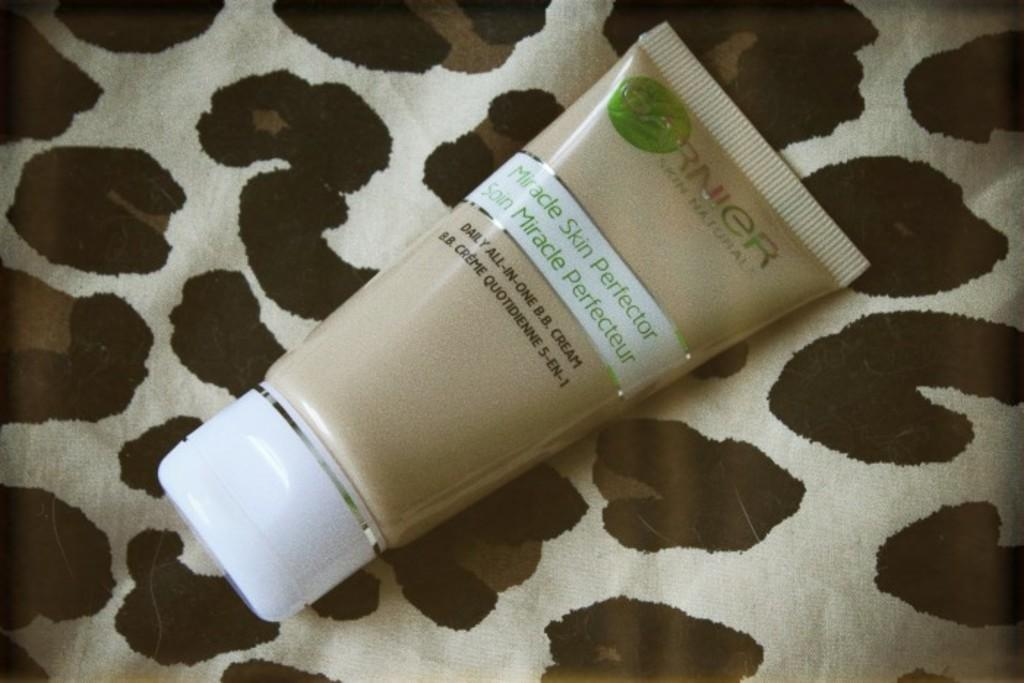<image>
Present a compact description of the photo's key features. A tube of Garnier Miracle skin perfector on an animal print cloth. 